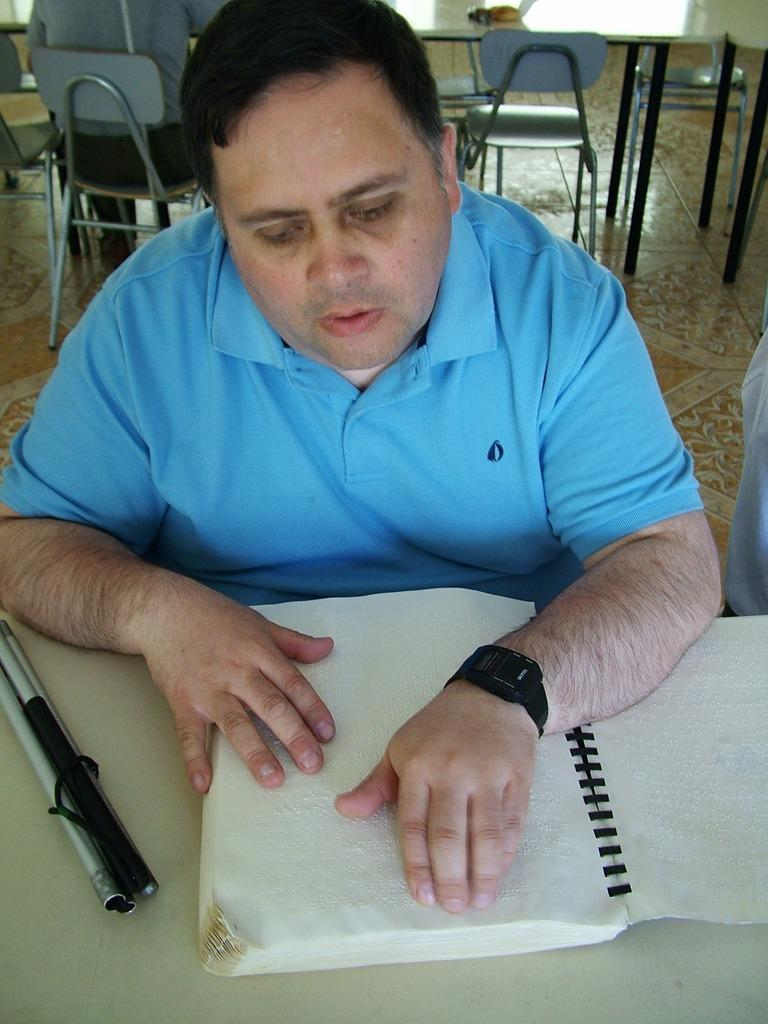What object is placed on the table in the image? There is a book on the table. What other object can be seen on the table? There is a stick on the table. How many people are seated in the image? There are three people seated on chairs. What mountain can be seen in the background of the image? There is no mountain visible in the image; it only shows a table with a book and a stick, as well as three people seated on chairs. 